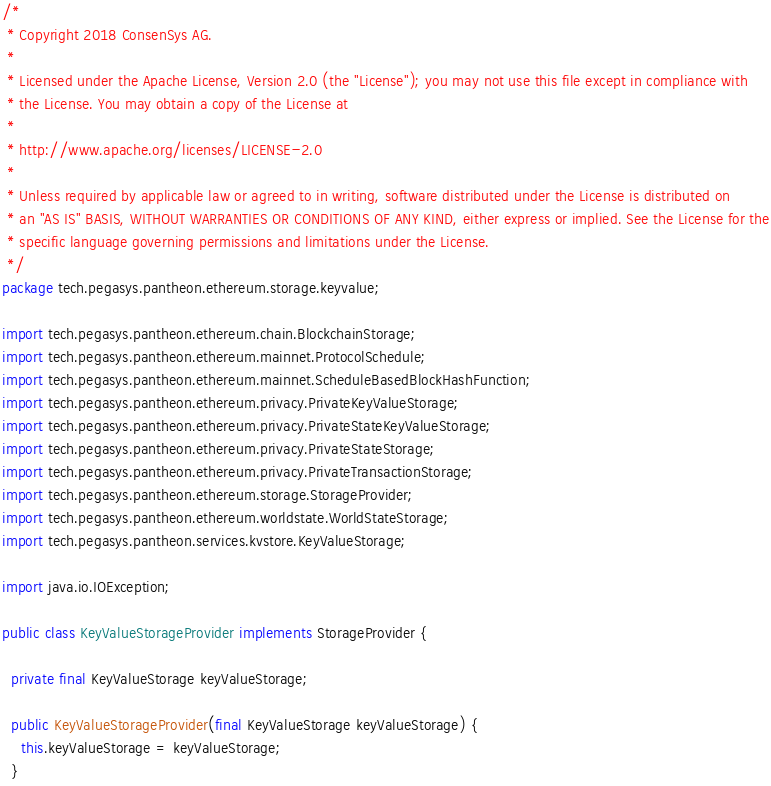Convert code to text. <code><loc_0><loc_0><loc_500><loc_500><_Java_>/*
 * Copyright 2018 ConsenSys AG.
 *
 * Licensed under the Apache License, Version 2.0 (the "License"); you may not use this file except in compliance with
 * the License. You may obtain a copy of the License at
 *
 * http://www.apache.org/licenses/LICENSE-2.0
 *
 * Unless required by applicable law or agreed to in writing, software distributed under the License is distributed on
 * an "AS IS" BASIS, WITHOUT WARRANTIES OR CONDITIONS OF ANY KIND, either express or implied. See the License for the
 * specific language governing permissions and limitations under the License.
 */
package tech.pegasys.pantheon.ethereum.storage.keyvalue;

import tech.pegasys.pantheon.ethereum.chain.BlockchainStorage;
import tech.pegasys.pantheon.ethereum.mainnet.ProtocolSchedule;
import tech.pegasys.pantheon.ethereum.mainnet.ScheduleBasedBlockHashFunction;
import tech.pegasys.pantheon.ethereum.privacy.PrivateKeyValueStorage;
import tech.pegasys.pantheon.ethereum.privacy.PrivateStateKeyValueStorage;
import tech.pegasys.pantheon.ethereum.privacy.PrivateStateStorage;
import tech.pegasys.pantheon.ethereum.privacy.PrivateTransactionStorage;
import tech.pegasys.pantheon.ethereum.storage.StorageProvider;
import tech.pegasys.pantheon.ethereum.worldstate.WorldStateStorage;
import tech.pegasys.pantheon.services.kvstore.KeyValueStorage;

import java.io.IOException;

public class KeyValueStorageProvider implements StorageProvider {

  private final KeyValueStorage keyValueStorage;

  public KeyValueStorageProvider(final KeyValueStorage keyValueStorage) {
    this.keyValueStorage = keyValueStorage;
  }
</code> 